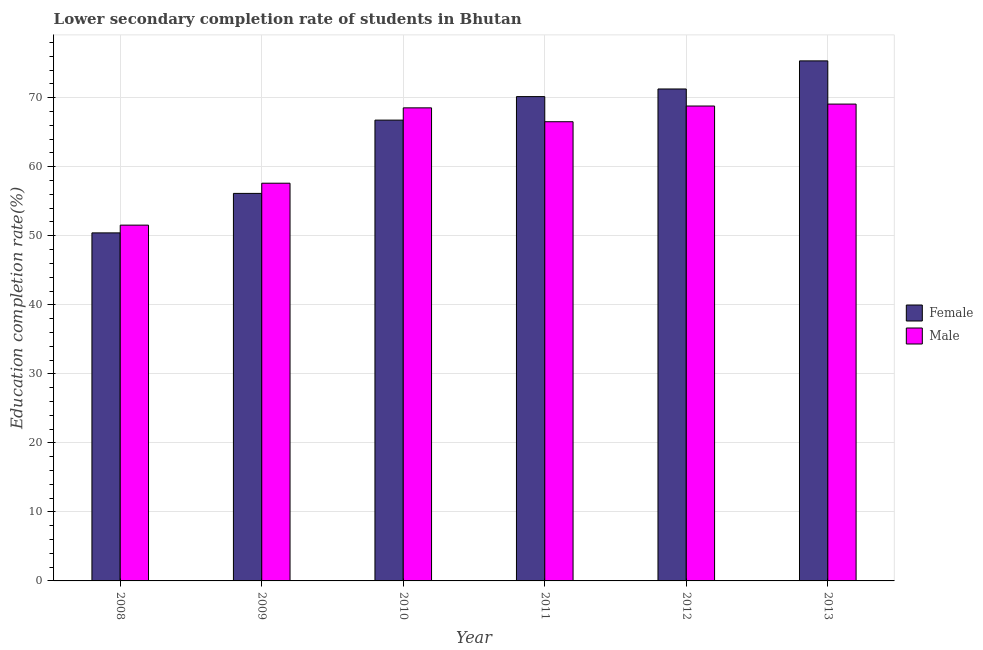How many different coloured bars are there?
Keep it short and to the point. 2. How many groups of bars are there?
Your answer should be compact. 6. How many bars are there on the 3rd tick from the left?
Your answer should be compact. 2. How many bars are there on the 6th tick from the right?
Give a very brief answer. 2. What is the label of the 2nd group of bars from the left?
Offer a very short reply. 2009. In how many cases, is the number of bars for a given year not equal to the number of legend labels?
Offer a terse response. 0. What is the education completion rate of male students in 2010?
Ensure brevity in your answer.  68.53. Across all years, what is the maximum education completion rate of female students?
Give a very brief answer. 75.34. Across all years, what is the minimum education completion rate of female students?
Offer a very short reply. 50.42. What is the total education completion rate of male students in the graph?
Ensure brevity in your answer.  382.1. What is the difference between the education completion rate of female students in 2009 and that in 2012?
Provide a short and direct response. -15.13. What is the difference between the education completion rate of female students in 2011 and the education completion rate of male students in 2012?
Give a very brief answer. -1.1. What is the average education completion rate of male students per year?
Your answer should be compact. 63.68. In how many years, is the education completion rate of female students greater than 32 %?
Ensure brevity in your answer.  6. What is the ratio of the education completion rate of male students in 2009 to that in 2013?
Your response must be concise. 0.83. What is the difference between the highest and the second highest education completion rate of male students?
Offer a terse response. 0.28. What is the difference between the highest and the lowest education completion rate of male students?
Provide a short and direct response. 17.54. In how many years, is the education completion rate of male students greater than the average education completion rate of male students taken over all years?
Your answer should be very brief. 4. What does the 1st bar from the left in 2009 represents?
Your response must be concise. Female. What does the 1st bar from the right in 2009 represents?
Provide a short and direct response. Male. How many bars are there?
Give a very brief answer. 12. What is the difference between two consecutive major ticks on the Y-axis?
Ensure brevity in your answer.  10. Are the values on the major ticks of Y-axis written in scientific E-notation?
Keep it short and to the point. No. Does the graph contain any zero values?
Offer a terse response. No. How many legend labels are there?
Offer a very short reply. 2. What is the title of the graph?
Make the answer very short. Lower secondary completion rate of students in Bhutan. Does "Age 65(female)" appear as one of the legend labels in the graph?
Make the answer very short. No. What is the label or title of the Y-axis?
Offer a terse response. Education completion rate(%). What is the Education completion rate(%) of Female in 2008?
Your answer should be very brief. 50.42. What is the Education completion rate(%) of Male in 2008?
Your response must be concise. 51.54. What is the Education completion rate(%) in Female in 2009?
Provide a succinct answer. 56.14. What is the Education completion rate(%) of Male in 2009?
Your response must be concise. 57.62. What is the Education completion rate(%) in Female in 2010?
Keep it short and to the point. 66.76. What is the Education completion rate(%) of Male in 2010?
Offer a terse response. 68.53. What is the Education completion rate(%) of Female in 2011?
Keep it short and to the point. 70.16. What is the Education completion rate(%) of Male in 2011?
Provide a succinct answer. 66.52. What is the Education completion rate(%) in Female in 2012?
Provide a succinct answer. 71.27. What is the Education completion rate(%) in Male in 2012?
Your answer should be very brief. 68.8. What is the Education completion rate(%) in Female in 2013?
Give a very brief answer. 75.34. What is the Education completion rate(%) in Male in 2013?
Offer a very short reply. 69.08. Across all years, what is the maximum Education completion rate(%) in Female?
Provide a short and direct response. 75.34. Across all years, what is the maximum Education completion rate(%) of Male?
Keep it short and to the point. 69.08. Across all years, what is the minimum Education completion rate(%) in Female?
Ensure brevity in your answer.  50.42. Across all years, what is the minimum Education completion rate(%) of Male?
Offer a very short reply. 51.54. What is the total Education completion rate(%) of Female in the graph?
Your response must be concise. 390.09. What is the total Education completion rate(%) of Male in the graph?
Your response must be concise. 382.1. What is the difference between the Education completion rate(%) in Female in 2008 and that in 2009?
Your answer should be compact. -5.72. What is the difference between the Education completion rate(%) of Male in 2008 and that in 2009?
Give a very brief answer. -6.07. What is the difference between the Education completion rate(%) of Female in 2008 and that in 2010?
Your answer should be very brief. -16.34. What is the difference between the Education completion rate(%) in Male in 2008 and that in 2010?
Your answer should be compact. -16.99. What is the difference between the Education completion rate(%) of Female in 2008 and that in 2011?
Provide a succinct answer. -19.74. What is the difference between the Education completion rate(%) of Male in 2008 and that in 2011?
Keep it short and to the point. -14.98. What is the difference between the Education completion rate(%) of Female in 2008 and that in 2012?
Provide a succinct answer. -20.85. What is the difference between the Education completion rate(%) in Male in 2008 and that in 2012?
Your answer should be compact. -17.25. What is the difference between the Education completion rate(%) in Female in 2008 and that in 2013?
Make the answer very short. -24.92. What is the difference between the Education completion rate(%) in Male in 2008 and that in 2013?
Your answer should be compact. -17.54. What is the difference between the Education completion rate(%) of Female in 2009 and that in 2010?
Provide a succinct answer. -10.61. What is the difference between the Education completion rate(%) in Male in 2009 and that in 2010?
Your response must be concise. -10.92. What is the difference between the Education completion rate(%) in Female in 2009 and that in 2011?
Offer a very short reply. -14.02. What is the difference between the Education completion rate(%) of Male in 2009 and that in 2011?
Give a very brief answer. -8.91. What is the difference between the Education completion rate(%) in Female in 2009 and that in 2012?
Provide a short and direct response. -15.13. What is the difference between the Education completion rate(%) in Male in 2009 and that in 2012?
Ensure brevity in your answer.  -11.18. What is the difference between the Education completion rate(%) in Female in 2009 and that in 2013?
Ensure brevity in your answer.  -19.2. What is the difference between the Education completion rate(%) of Male in 2009 and that in 2013?
Provide a short and direct response. -11.46. What is the difference between the Education completion rate(%) of Female in 2010 and that in 2011?
Your answer should be very brief. -3.41. What is the difference between the Education completion rate(%) in Male in 2010 and that in 2011?
Offer a very short reply. 2.01. What is the difference between the Education completion rate(%) in Female in 2010 and that in 2012?
Offer a very short reply. -4.51. What is the difference between the Education completion rate(%) in Male in 2010 and that in 2012?
Make the answer very short. -0.26. What is the difference between the Education completion rate(%) in Female in 2010 and that in 2013?
Offer a very short reply. -8.58. What is the difference between the Education completion rate(%) of Male in 2010 and that in 2013?
Make the answer very short. -0.54. What is the difference between the Education completion rate(%) of Female in 2011 and that in 2012?
Your answer should be compact. -1.1. What is the difference between the Education completion rate(%) in Male in 2011 and that in 2012?
Offer a terse response. -2.28. What is the difference between the Education completion rate(%) of Female in 2011 and that in 2013?
Make the answer very short. -5.17. What is the difference between the Education completion rate(%) in Male in 2011 and that in 2013?
Your answer should be very brief. -2.56. What is the difference between the Education completion rate(%) in Female in 2012 and that in 2013?
Ensure brevity in your answer.  -4.07. What is the difference between the Education completion rate(%) in Male in 2012 and that in 2013?
Provide a short and direct response. -0.28. What is the difference between the Education completion rate(%) in Female in 2008 and the Education completion rate(%) in Male in 2009?
Offer a terse response. -7.2. What is the difference between the Education completion rate(%) of Female in 2008 and the Education completion rate(%) of Male in 2010?
Your answer should be compact. -18.12. What is the difference between the Education completion rate(%) in Female in 2008 and the Education completion rate(%) in Male in 2011?
Provide a succinct answer. -16.1. What is the difference between the Education completion rate(%) of Female in 2008 and the Education completion rate(%) of Male in 2012?
Offer a terse response. -18.38. What is the difference between the Education completion rate(%) in Female in 2008 and the Education completion rate(%) in Male in 2013?
Make the answer very short. -18.66. What is the difference between the Education completion rate(%) of Female in 2009 and the Education completion rate(%) of Male in 2010?
Ensure brevity in your answer.  -12.39. What is the difference between the Education completion rate(%) in Female in 2009 and the Education completion rate(%) in Male in 2011?
Your answer should be very brief. -10.38. What is the difference between the Education completion rate(%) of Female in 2009 and the Education completion rate(%) of Male in 2012?
Provide a succinct answer. -12.66. What is the difference between the Education completion rate(%) in Female in 2009 and the Education completion rate(%) in Male in 2013?
Offer a terse response. -12.94. What is the difference between the Education completion rate(%) in Female in 2010 and the Education completion rate(%) in Male in 2011?
Make the answer very short. 0.23. What is the difference between the Education completion rate(%) in Female in 2010 and the Education completion rate(%) in Male in 2012?
Your answer should be compact. -2.04. What is the difference between the Education completion rate(%) of Female in 2010 and the Education completion rate(%) of Male in 2013?
Provide a succinct answer. -2.32. What is the difference between the Education completion rate(%) of Female in 2011 and the Education completion rate(%) of Male in 2012?
Keep it short and to the point. 1.36. What is the difference between the Education completion rate(%) in Female in 2011 and the Education completion rate(%) in Male in 2013?
Ensure brevity in your answer.  1.08. What is the difference between the Education completion rate(%) in Female in 2012 and the Education completion rate(%) in Male in 2013?
Keep it short and to the point. 2.19. What is the average Education completion rate(%) of Female per year?
Keep it short and to the point. 65.01. What is the average Education completion rate(%) in Male per year?
Make the answer very short. 63.68. In the year 2008, what is the difference between the Education completion rate(%) in Female and Education completion rate(%) in Male?
Ensure brevity in your answer.  -1.12. In the year 2009, what is the difference between the Education completion rate(%) of Female and Education completion rate(%) of Male?
Give a very brief answer. -1.48. In the year 2010, what is the difference between the Education completion rate(%) of Female and Education completion rate(%) of Male?
Provide a succinct answer. -1.78. In the year 2011, what is the difference between the Education completion rate(%) of Female and Education completion rate(%) of Male?
Your answer should be very brief. 3.64. In the year 2012, what is the difference between the Education completion rate(%) of Female and Education completion rate(%) of Male?
Your response must be concise. 2.47. In the year 2013, what is the difference between the Education completion rate(%) of Female and Education completion rate(%) of Male?
Ensure brevity in your answer.  6.26. What is the ratio of the Education completion rate(%) of Female in 2008 to that in 2009?
Ensure brevity in your answer.  0.9. What is the ratio of the Education completion rate(%) in Male in 2008 to that in 2009?
Your response must be concise. 0.89. What is the ratio of the Education completion rate(%) in Female in 2008 to that in 2010?
Offer a very short reply. 0.76. What is the ratio of the Education completion rate(%) of Male in 2008 to that in 2010?
Provide a short and direct response. 0.75. What is the ratio of the Education completion rate(%) of Female in 2008 to that in 2011?
Your answer should be compact. 0.72. What is the ratio of the Education completion rate(%) in Male in 2008 to that in 2011?
Keep it short and to the point. 0.77. What is the ratio of the Education completion rate(%) of Female in 2008 to that in 2012?
Your answer should be very brief. 0.71. What is the ratio of the Education completion rate(%) of Male in 2008 to that in 2012?
Provide a short and direct response. 0.75. What is the ratio of the Education completion rate(%) of Female in 2008 to that in 2013?
Your response must be concise. 0.67. What is the ratio of the Education completion rate(%) of Male in 2008 to that in 2013?
Offer a very short reply. 0.75. What is the ratio of the Education completion rate(%) in Female in 2009 to that in 2010?
Provide a short and direct response. 0.84. What is the ratio of the Education completion rate(%) in Male in 2009 to that in 2010?
Keep it short and to the point. 0.84. What is the ratio of the Education completion rate(%) of Female in 2009 to that in 2011?
Provide a succinct answer. 0.8. What is the ratio of the Education completion rate(%) of Male in 2009 to that in 2011?
Offer a terse response. 0.87. What is the ratio of the Education completion rate(%) in Female in 2009 to that in 2012?
Your answer should be compact. 0.79. What is the ratio of the Education completion rate(%) of Male in 2009 to that in 2012?
Provide a succinct answer. 0.84. What is the ratio of the Education completion rate(%) of Female in 2009 to that in 2013?
Provide a short and direct response. 0.75. What is the ratio of the Education completion rate(%) of Male in 2009 to that in 2013?
Your answer should be compact. 0.83. What is the ratio of the Education completion rate(%) of Female in 2010 to that in 2011?
Ensure brevity in your answer.  0.95. What is the ratio of the Education completion rate(%) in Male in 2010 to that in 2011?
Provide a short and direct response. 1.03. What is the ratio of the Education completion rate(%) in Female in 2010 to that in 2012?
Make the answer very short. 0.94. What is the ratio of the Education completion rate(%) in Female in 2010 to that in 2013?
Offer a terse response. 0.89. What is the ratio of the Education completion rate(%) of Male in 2010 to that in 2013?
Keep it short and to the point. 0.99. What is the ratio of the Education completion rate(%) in Female in 2011 to that in 2012?
Offer a terse response. 0.98. What is the ratio of the Education completion rate(%) of Male in 2011 to that in 2012?
Make the answer very short. 0.97. What is the ratio of the Education completion rate(%) of Female in 2011 to that in 2013?
Your answer should be very brief. 0.93. What is the ratio of the Education completion rate(%) of Female in 2012 to that in 2013?
Your answer should be very brief. 0.95. What is the ratio of the Education completion rate(%) in Male in 2012 to that in 2013?
Provide a short and direct response. 1. What is the difference between the highest and the second highest Education completion rate(%) in Female?
Your response must be concise. 4.07. What is the difference between the highest and the second highest Education completion rate(%) in Male?
Offer a very short reply. 0.28. What is the difference between the highest and the lowest Education completion rate(%) in Female?
Your answer should be compact. 24.92. What is the difference between the highest and the lowest Education completion rate(%) in Male?
Provide a succinct answer. 17.54. 